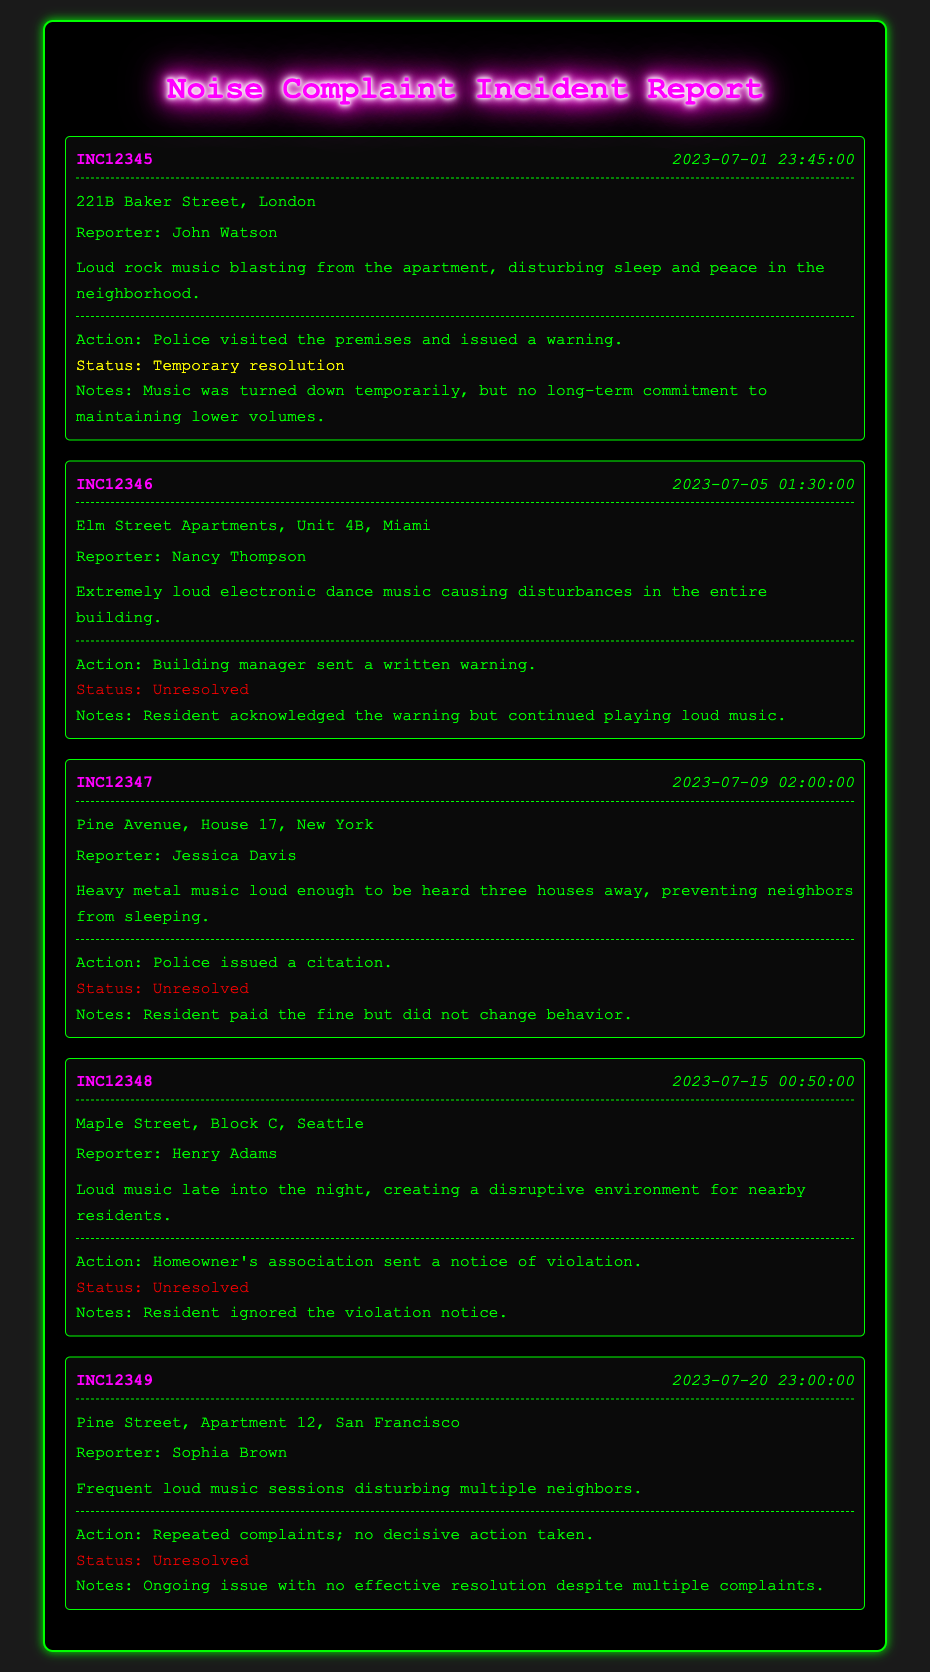what is the incident ID for the report on July 1st? The incident ID is presented prominently in each report section. For July 1st, it is INC12345.
Answer: INC12345 who reported the loud music incident at Elm Street Apartments? Each report includes the name of the reporter which is indicated right after the location. For Elm Street Apartments, the reporter is Nancy Thompson.
Answer: Nancy Thompson what was the action taken for the incident reported on July 9th? The action taken is specified within the response section of each incident. For July 9th, the action was that police issued a citation.
Answer: Police issued a citation how many incidents remain unresolved according to the report? By reviewing the resolution statuses noted in the responses, we can count the unresolved incidents. There are four unresolved incidents indicated.
Answer: 4 what type of music was reported by Jessica Davis? The specific type of music is mentioned in the description of the incident. For Jessica Davis, it was heavy metal music.
Answer: Heavy metal music what was the time of the incident at Maple Street? The time is included in the incident header and denotes when the incident occurred. The time of the incident at Maple Street was 00:50:00.
Answer: 00:50:00 what status did the residents have after paying the fine in the July 9th incident? The status following the actions taken is documented under each incident's response. For the July 9th incident, the status after paying the fine remained unresolved.
Answer: Unresolved which location had complaints about loud electronic dance music? The location is specified for each incident and directly relates to the description of the complaint. Complaints about loud electronic dance music were reported at Elm Street Apartments.
Answer: Elm Street Apartments 